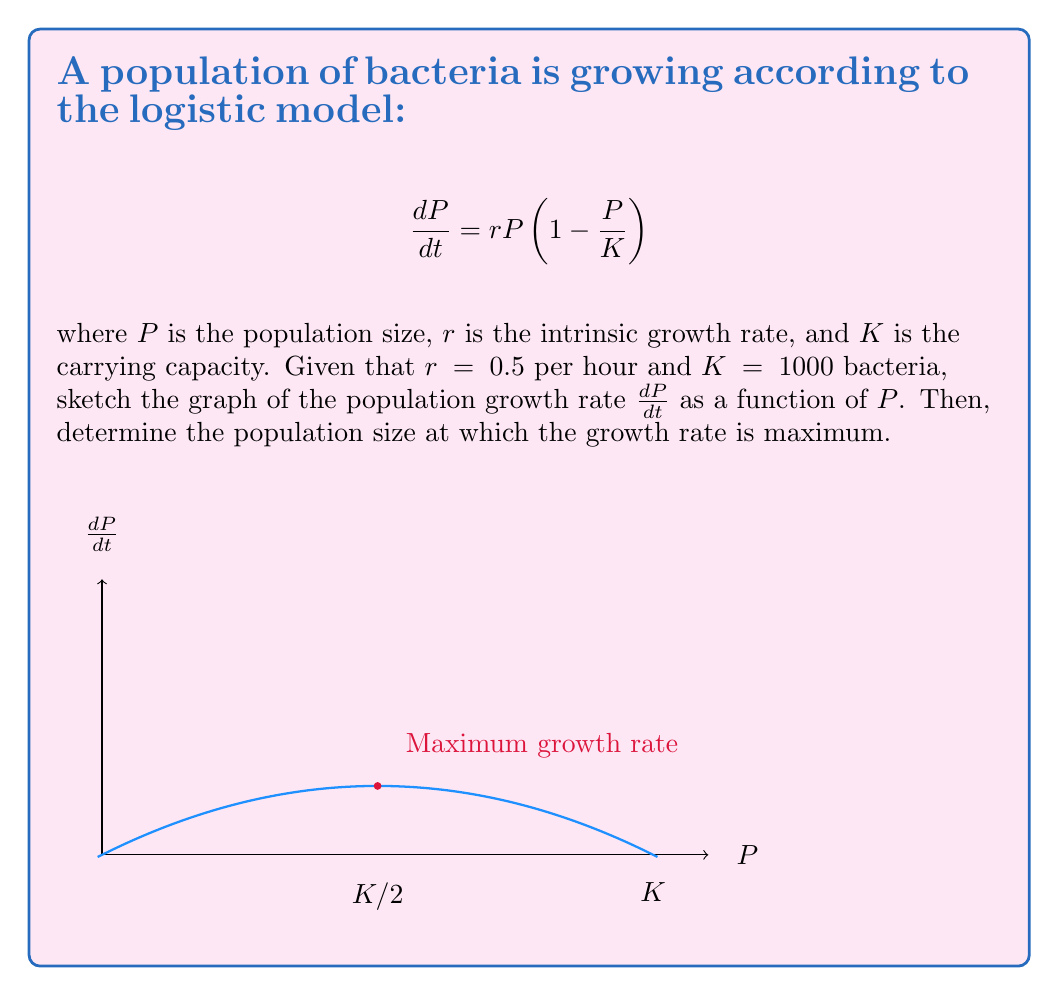Teach me how to tackle this problem. Let's approach this step-by-step:

1) The logistic growth model is given by:

   $$\frac{dP}{dt} = rP\left(1 - \frac{P}{K}\right)$$

2) We can expand this equation:

   $$\frac{dP}{dt} = rP - \frac{rP^2}{K}$$

3) This is a quadratic function in terms of $P$. The graph will be a parabola opening downwards.

4) To find the maximum point, we need to find where the derivative of this function with respect to $P$ is zero:

   $$\frac{d}{dP}\left(\frac{dP}{dt}\right) = r - \frac{2rP}{K} = 0$$

5) Solving this equation:

   $$r - \frac{2rP}{K} = 0$$
   $$r = \frac{2rP}{K}$$
   $$K = 2P$$
   $$P = \frac{K}{2}$$

6) Therefore, the population size at which the growth rate is maximum is $\frac{K}{2} = 500$ bacteria.

7) To find the maximum growth rate, we substitute this value back into the original equation:

   $$\frac{dP}{dt} = r\frac{K}{2}\left(1 - \frac{K/2}{K}\right) = r\frac{K}{2}\left(\frac{1}{2}\right) = \frac{rK}{4}$$

8) With the given values $r = 0.5$ and $K = 1000$, the maximum growth rate is:

   $$\frac{dP}{dt} = \frac{0.5 \times 1000}{4} = 125$$ bacteria per hour.

The graph shows a parabola starting at (0,0), reaching its peak at (500,125), and returning to zero at (1000,0).
Answer: Maximum growth rate occurs at $P = \frac{K}{2} = 500$ bacteria 